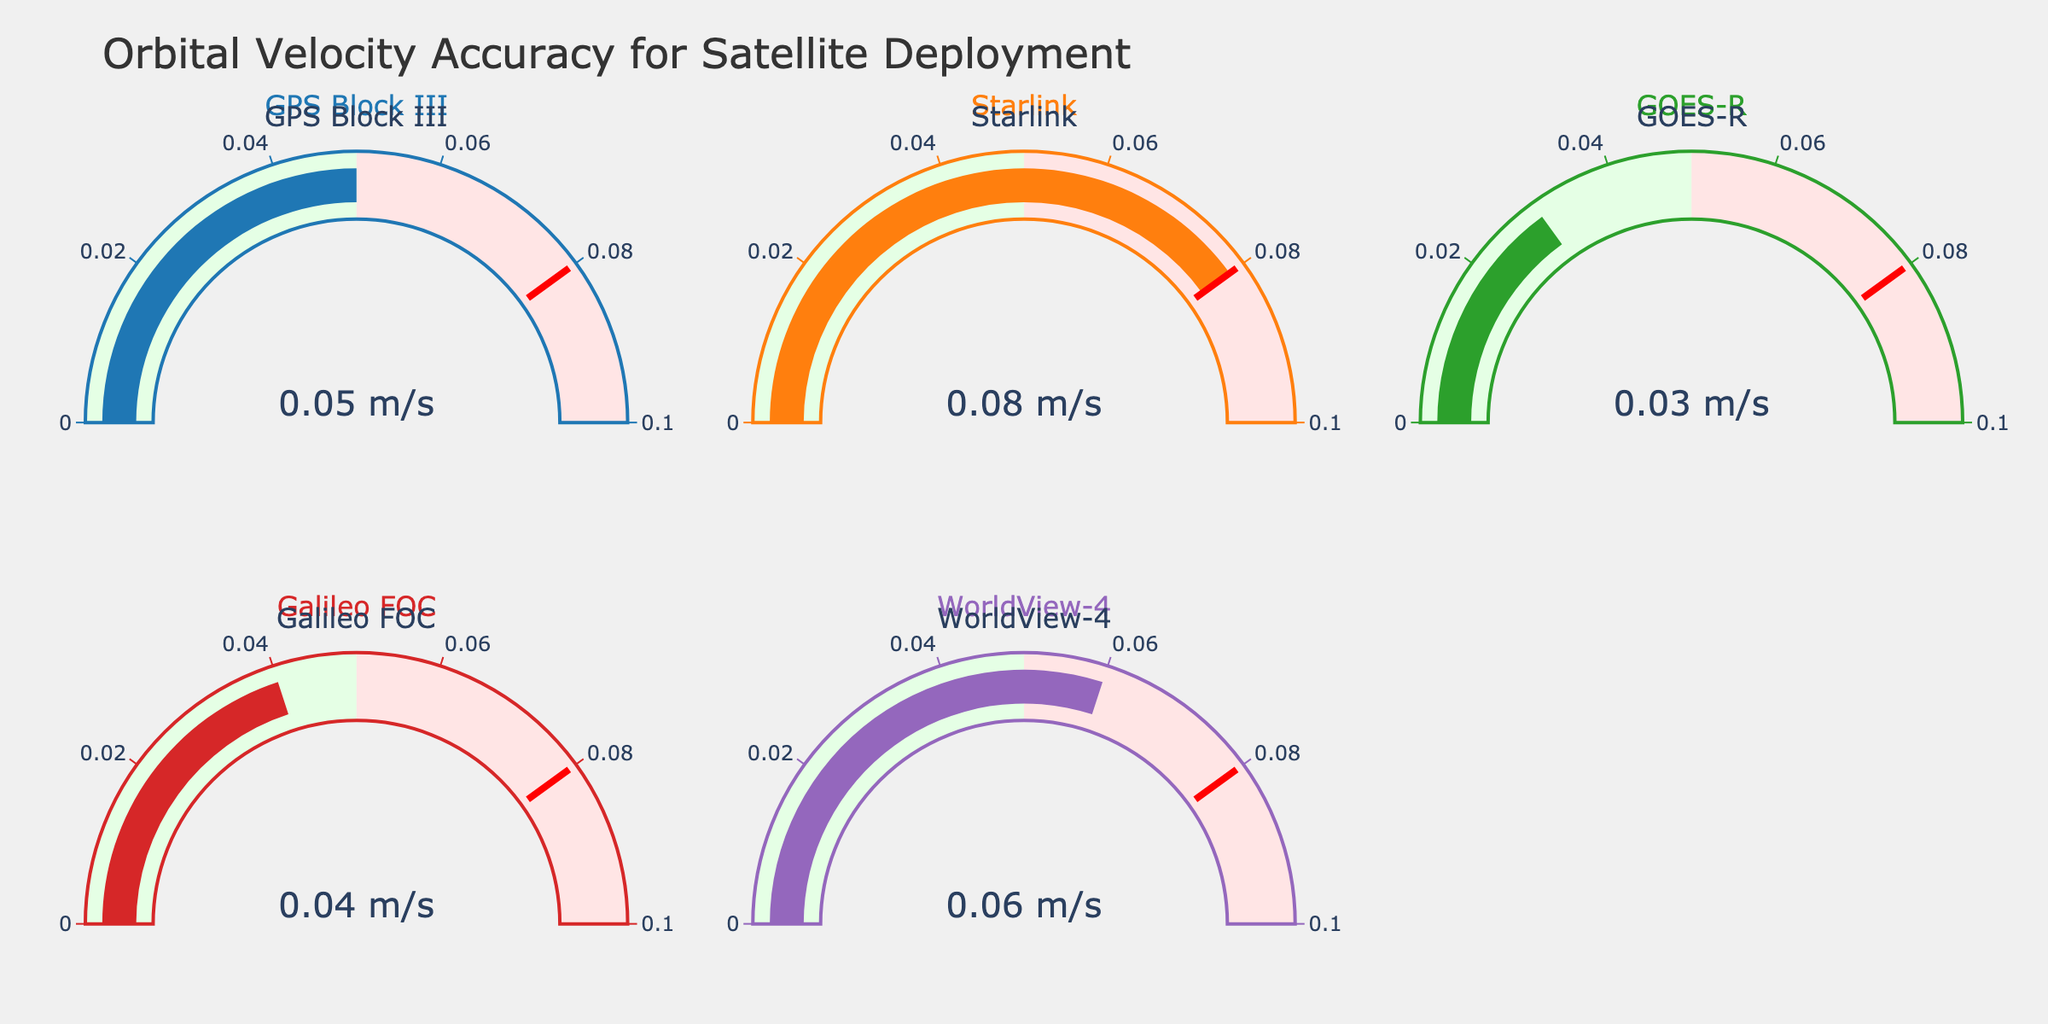What is the orbital velocity accuracy of the GPS Block III satellite? The GPS Block III satellite has an orbital velocity accuracy gauge, and the value displayed on the gauge is 0.05 m/s.
Answer: 0.05 m/s Which satellite has the highest orbital velocity accuracy value? By looking at all gauges, the Starlink satellite shows the highest value at 0.08 m/s.
Answer: Starlink Is the orbital velocity accuracy of Galileo FOC less than that of WorldView-4? The Galileo FOC satellite has an accuracy of 0.04 m/s, whereas the WorldView-4 has an accuracy of 0.06 m/s. 0.04 is indeed less than 0.06.
Answer: Yes What is the average orbital velocity accuracy of all the satellites? By summing up all the orbital velocity accuracies (0.05 + 0.08 + 0.03 + 0.04 + 0.06), which equals 0.26, and then dividing by the number of satellites (5), the average is 0.26 / 5 = 0.052.
Answer: 0.052 m/s Are there any satellites with an orbital velocity accuracy in the range of 0.05 to 0.1 m/s? The Starlink and WorldView-4 satellites have accuracies of 0.08 and 0.06 m/s, both of which fall within the range of 0.05 to 0.1 m/s.
Answer: Yes Which satellite has the lowest accuracy in terms of orbital velocity? The GOES-R satellite shows the lowest accuracy value on its gauge at 0.03 m/s.
Answer: GOES-R How many satellites have an orbital velocity accuracy less than 0.05 m/s? Considering the values, GPS Block III (0.05 m/s), Galileo FOC (0.04 m/s), and GOES-R (0.03 m/s) satisfy this condition. That counts to three satellites.
Answer: 3 Is the orbital velocity accuracy of WorldView-4 more than the threshold value? The threshold accuracy value on the gauge is 0.08 m/s, and WorldView-4 shows an accuracy of 0.06 m/s. Since 0.06 is less than 0.08, it does not exceed the threshold.
Answer: No If we sum up the orbital velocity accuracy of the GPS Block III and Starlink, what is the result? Adding the values of GPS Block III (0.05 m/s) and Starlink (0.08 m/s) yields 0.05 + 0.08 = 0.13 m/s.
Answer: 0.13 m/s 